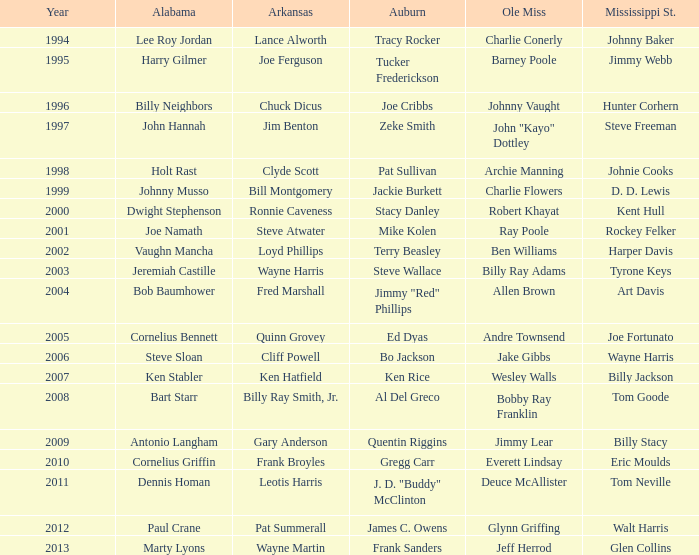Who was the Mississippi State player associated with Cornelius Bennett? Joe Fortunato. 